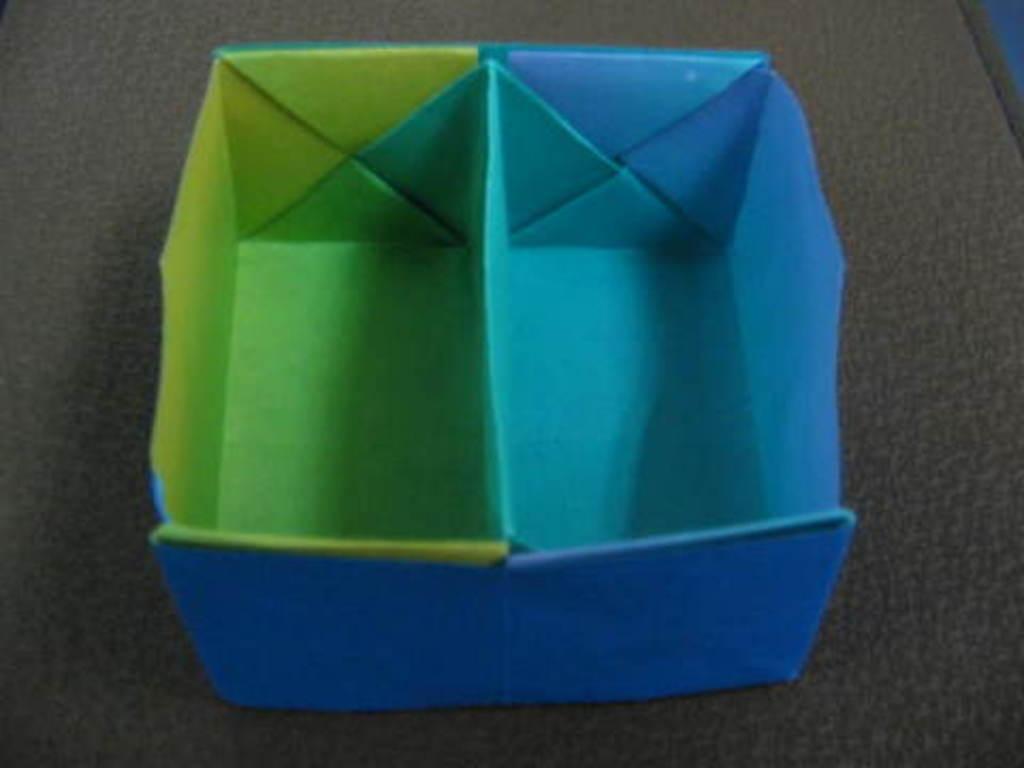Please provide a concise description of this image. In this image we can see a bowl made with paper is placed on a table. 